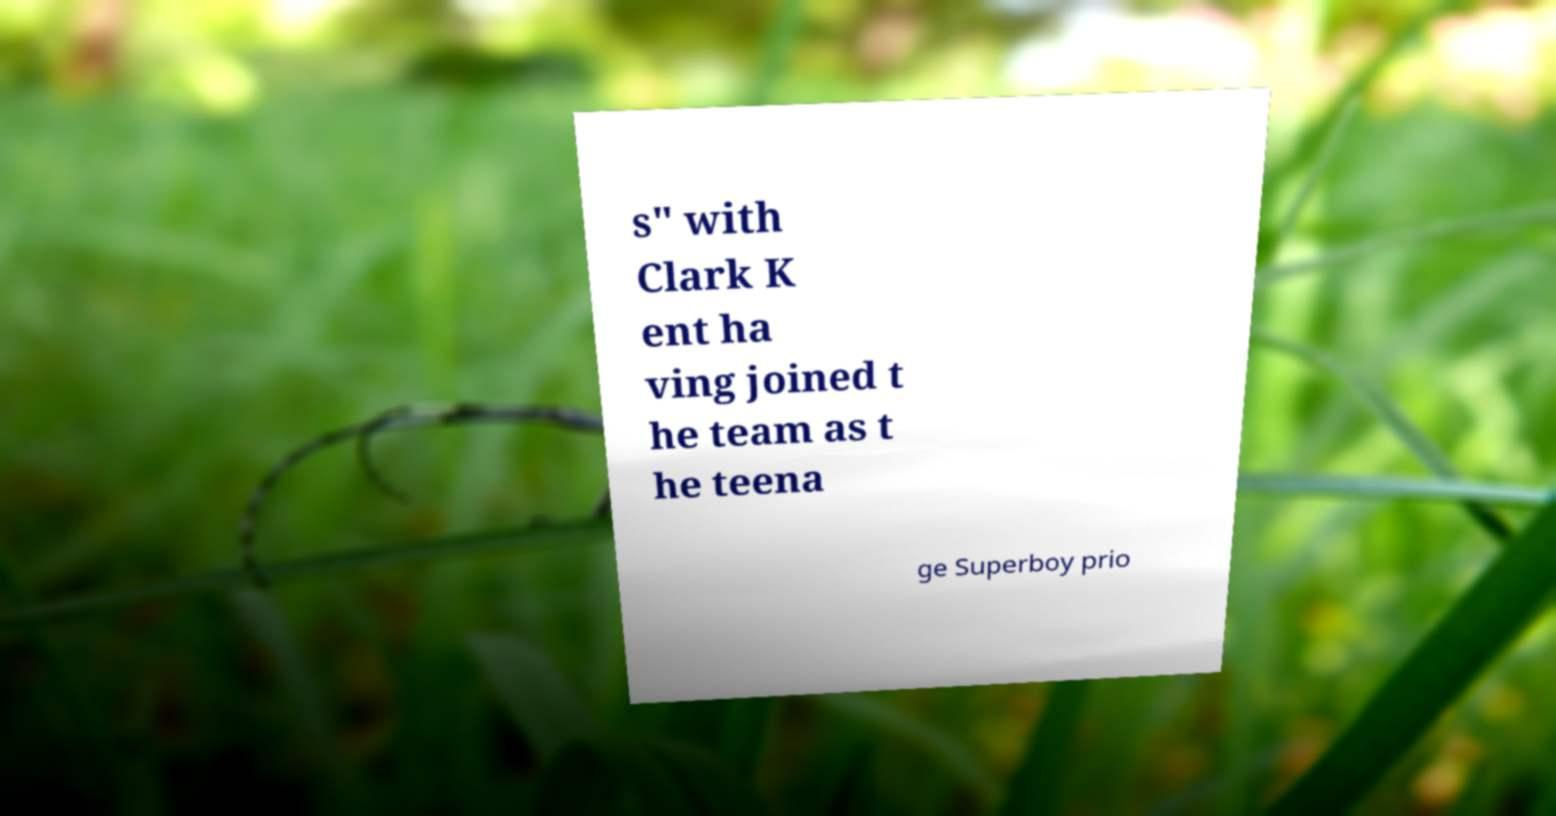Could you extract and type out the text from this image? s" with Clark K ent ha ving joined t he team as t he teena ge Superboy prio 